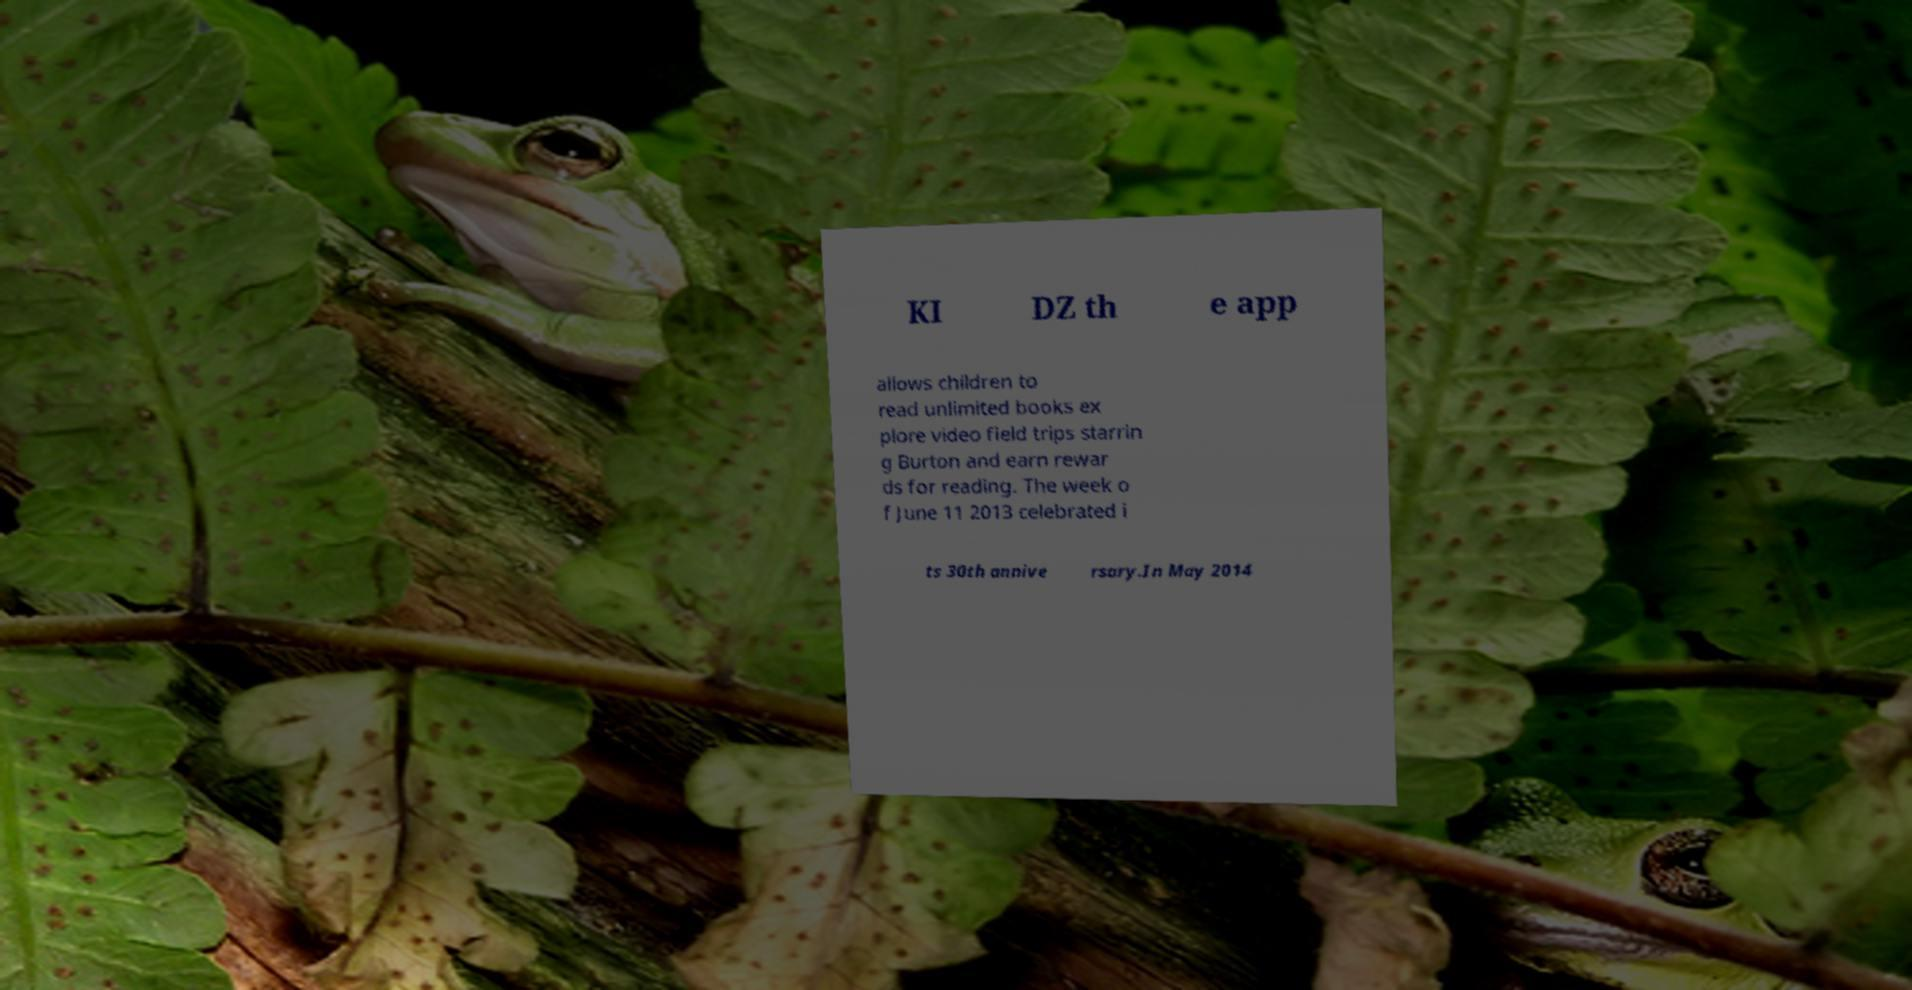Could you extract and type out the text from this image? KI DZ th e app allows children to read unlimited books ex plore video field trips starrin g Burton and earn rewar ds for reading. The week o f June 11 2013 celebrated i ts 30th annive rsary.In May 2014 